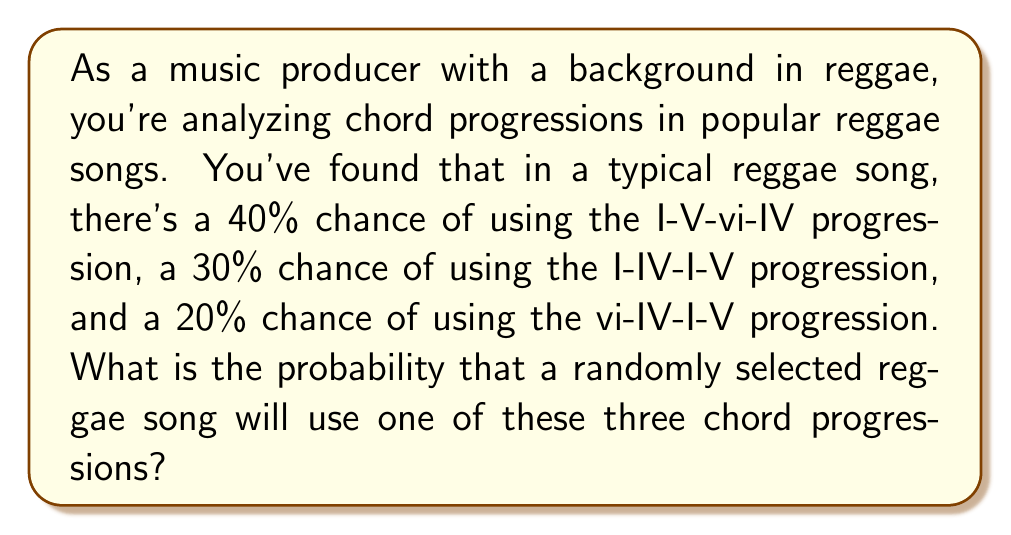Can you answer this question? To solve this problem, we need to use the addition rule of probability. Since the chord progressions are mutually exclusive (a song can only use one of these progressions at a time), we can simply add their individual probabilities.

Let's define our events:
$A$ = I-V-vi-IV progression
$B$ = I-IV-I-V progression
$C$ = vi-IV-I-V progression

Given:
$P(A) = 40\% = 0.40$
$P(B) = 30\% = 0.30$
$P(C) = 20\% = 0.20$

The probability of any of these progressions occurring is:

$$P(A \text{ or } B \text{ or } C) = P(A) + P(B) + P(C)$$

Substituting the values:

$$P(A \text{ or } B \text{ or } C) = 0.40 + 0.30 + 0.20 = 0.90$$

Therefore, the probability that a randomly selected reggae song will use one of these three chord progressions is 0.90 or 90%.
Answer: $0.90$ or $90\%$ 